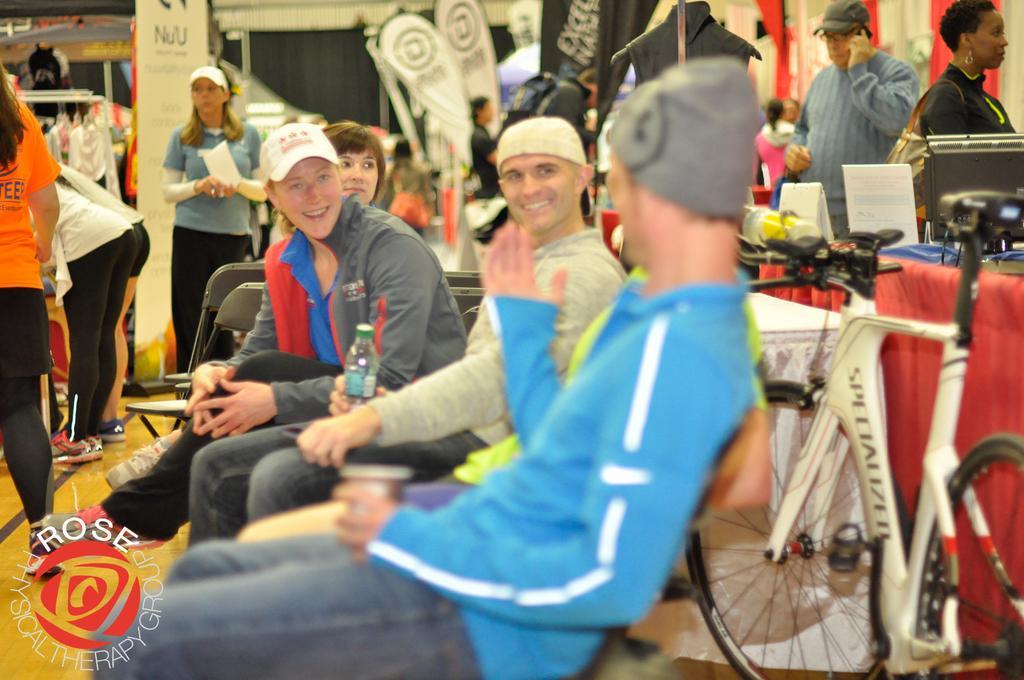Can you describe this image briefly? This picture is an inside view of a store. In the center of the image we can see some persons are sitting on the chairs. On the right side of the image we can see a bicycle, tables. On the tables we can see the cloths, boards, screen. On the left side of the image we can see the clothes and some persons are standing. In the background of the image we can see the wall, pillar, boards, door, light and some persons. At the bottom of the image we can see the floor. In the bottom left corner we can see the text and logo. 